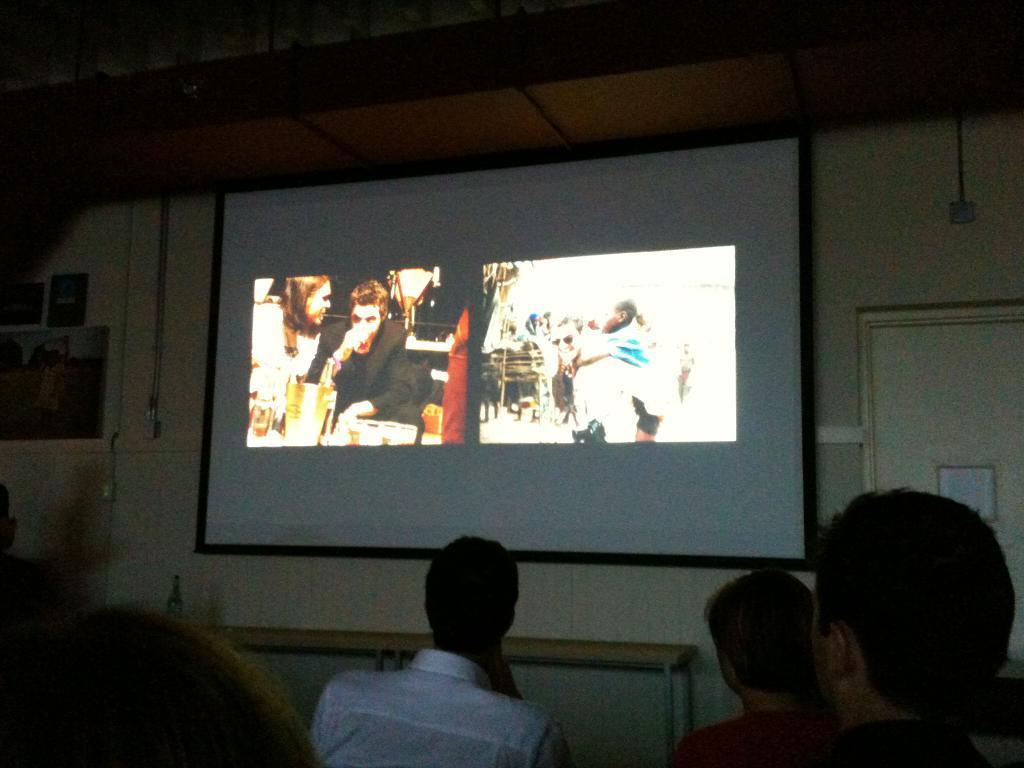Could you give a brief overview of what you see in this image? In the image we can see there is a white wall on which three photo frames are kept beside that there is a projector screen on which a photo is displayed. People are gathered to watch the projector screen. Beside the projector screen there is a white door and it is closed. 